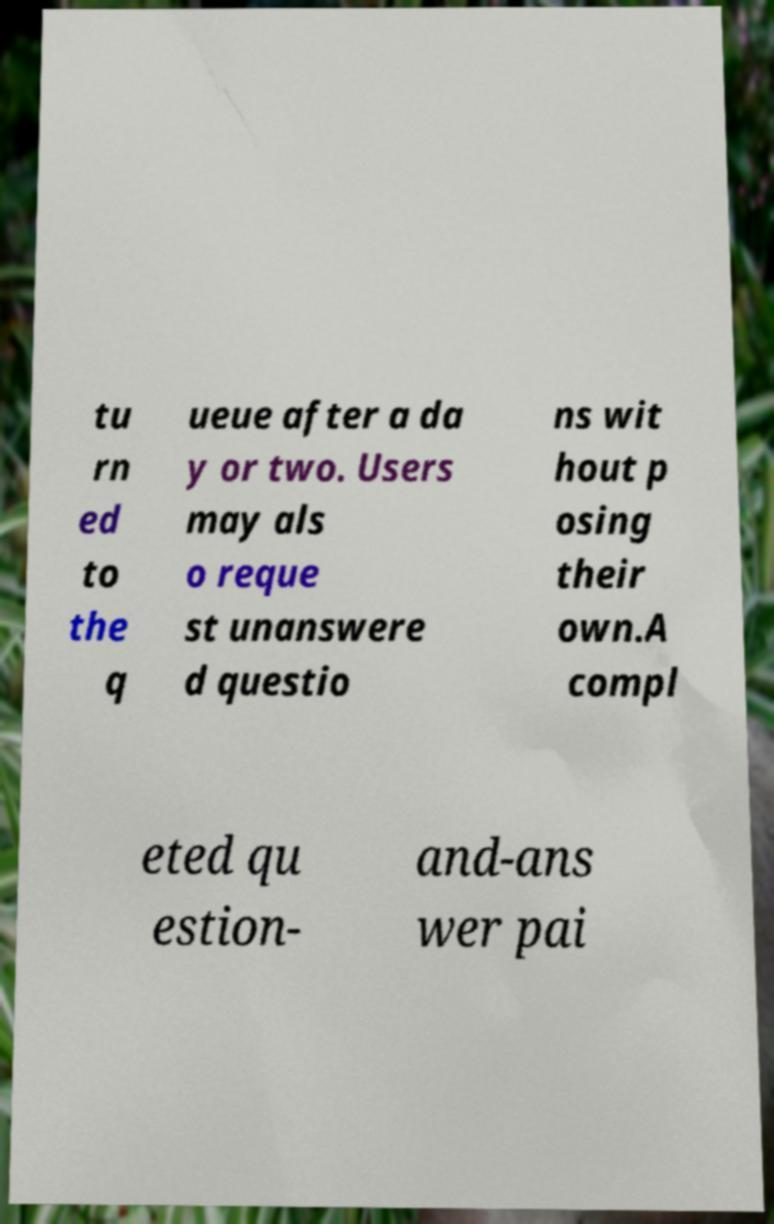Please identify and transcribe the text found in this image. tu rn ed to the q ueue after a da y or two. Users may als o reque st unanswere d questio ns wit hout p osing their own.A compl eted qu estion- and-ans wer pai 